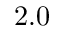<formula> <loc_0><loc_0><loc_500><loc_500>2 . 0</formula> 